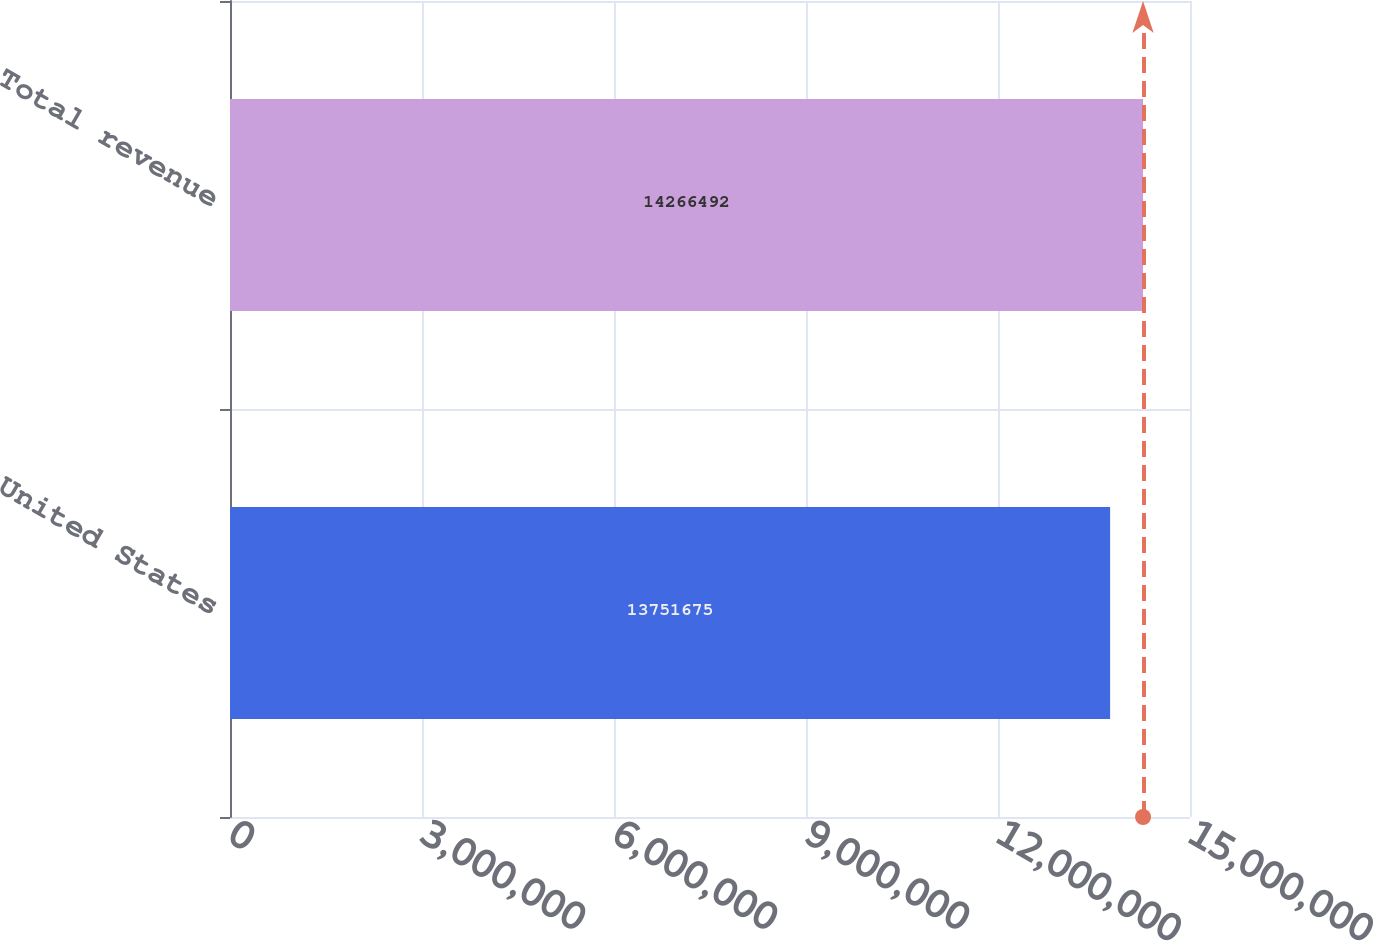Convert chart to OTSL. <chart><loc_0><loc_0><loc_500><loc_500><bar_chart><fcel>United States<fcel>Total revenue<nl><fcel>1.37517e+07<fcel>1.42665e+07<nl></chart> 